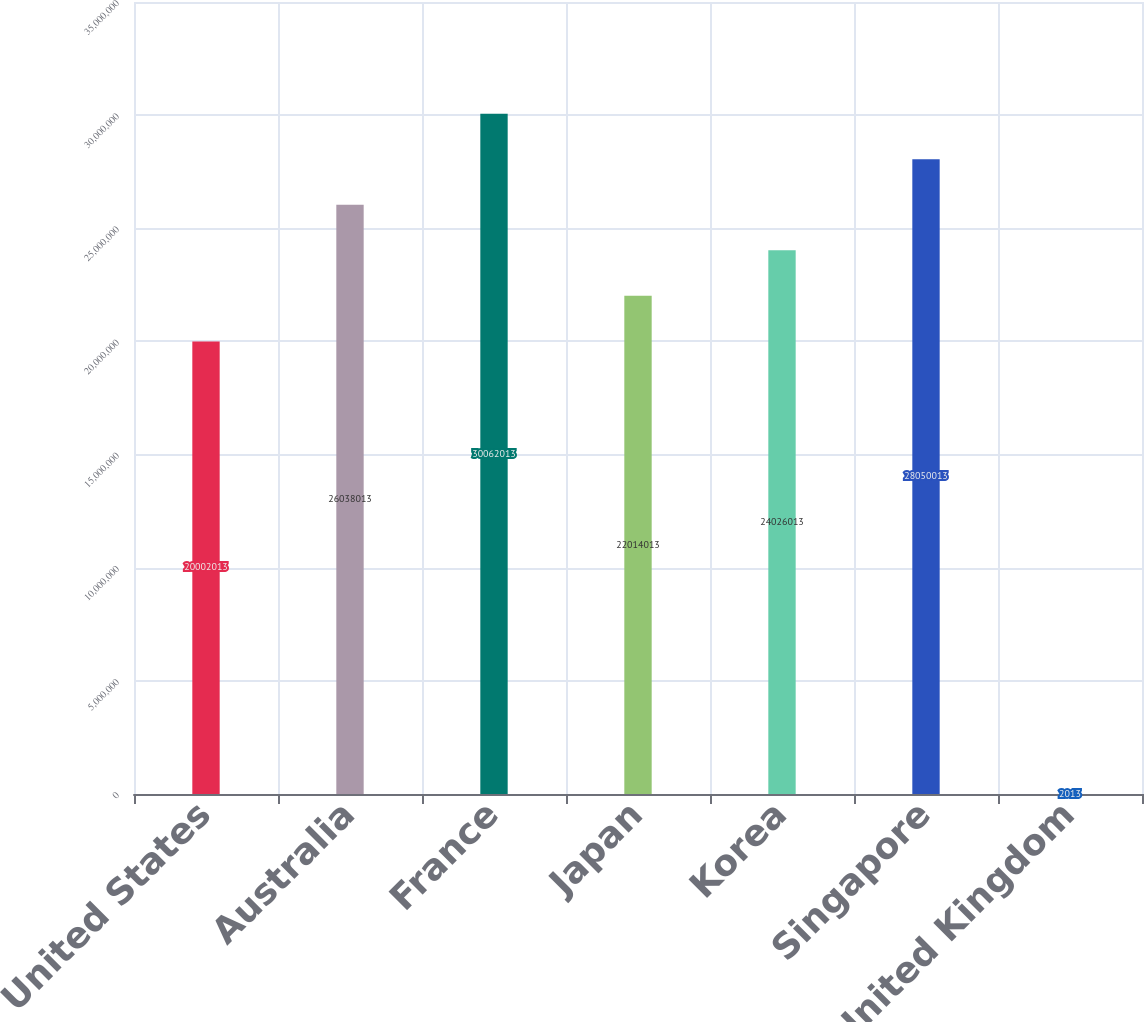<chart> <loc_0><loc_0><loc_500><loc_500><bar_chart><fcel>United States<fcel>Australia<fcel>France<fcel>Japan<fcel>Korea<fcel>Singapore<fcel>United Kingdom<nl><fcel>2.0002e+07<fcel>2.6038e+07<fcel>3.0062e+07<fcel>2.2014e+07<fcel>2.4026e+07<fcel>2.805e+07<fcel>2013<nl></chart> 